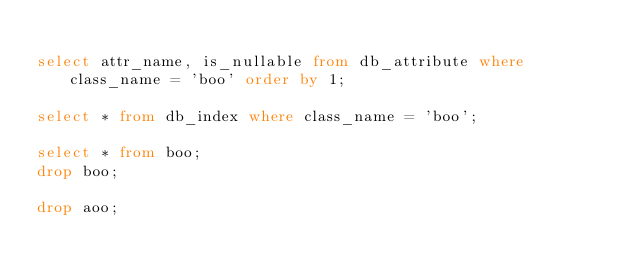<code> <loc_0><loc_0><loc_500><loc_500><_SQL_>
select attr_name, is_nullable from db_attribute where class_name = 'boo' order by 1;

select * from db_index where class_name = 'boo';

select * from boo;
drop boo;

drop aoo;
</code> 